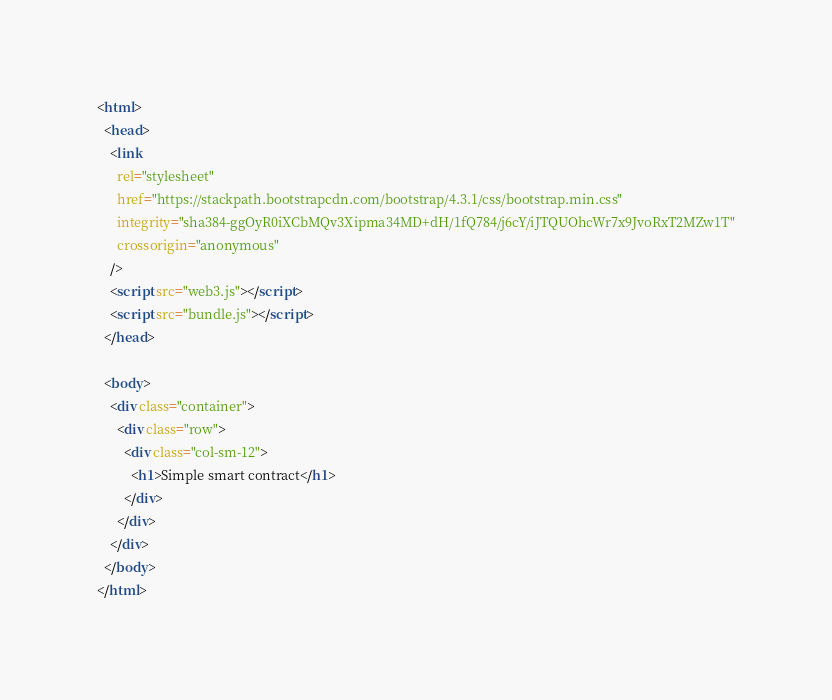<code> <loc_0><loc_0><loc_500><loc_500><_HTML_><html>
  <head>
    <link
      rel="stylesheet"
      href="https://stackpath.bootstrapcdn.com/bootstrap/4.3.1/css/bootstrap.min.css"
      integrity="sha384-ggOyR0iXCbMQv3Xipma34MD+dH/1fQ784/j6cY/iJTQUOhcWr7x9JvoRxT2MZw1T"
      crossorigin="anonymous"
    />
    <script src="web3.js"></script>
    <script src="bundle.js"></script>
  </head>

  <body>
    <div class="container">
      <div class="row">
        <div class="col-sm-12">
          <h1>Simple smart contract</h1>
        </div>
      </div>
    </div>
  </body>
</html>
</code> 